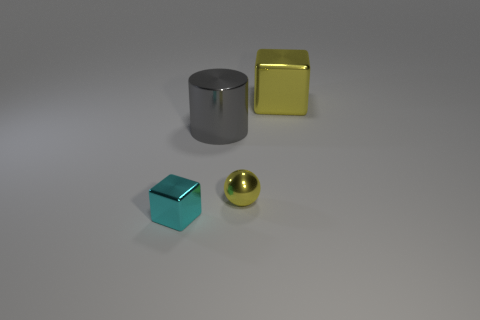Is there another large thing that has the same shape as the large yellow shiny thing?
Ensure brevity in your answer.  No. Is the color of the large cube the same as the big metallic cylinder?
Ensure brevity in your answer.  No. What is the material of the block in front of the yellow object left of the yellow metallic cube?
Offer a very short reply. Metal. How big is the cylinder?
Offer a very short reply. Large. There is a ball that is the same material as the cyan block; what size is it?
Your answer should be compact. Small. There is a shiny block that is behind the cyan shiny cube; is it the same size as the big gray cylinder?
Offer a very short reply. Yes. What is the shape of the small metal object right of the cube in front of the metal cube behind the big gray metallic cylinder?
Your answer should be compact. Sphere. How many objects are cyan cubes or blocks in front of the large yellow metallic thing?
Provide a short and direct response. 1. What is the size of the shiny block that is right of the cyan metallic thing?
Keep it short and to the point. Large. There is a thing that is the same color as the tiny sphere; what shape is it?
Your response must be concise. Cube. 